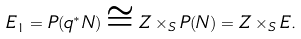Convert formula to latex. <formula><loc_0><loc_0><loc_500><loc_500>E _ { 1 } = P ( q ^ { * } N ) \cong Z \times _ { S } P ( N ) = Z \times _ { S } E .</formula> 